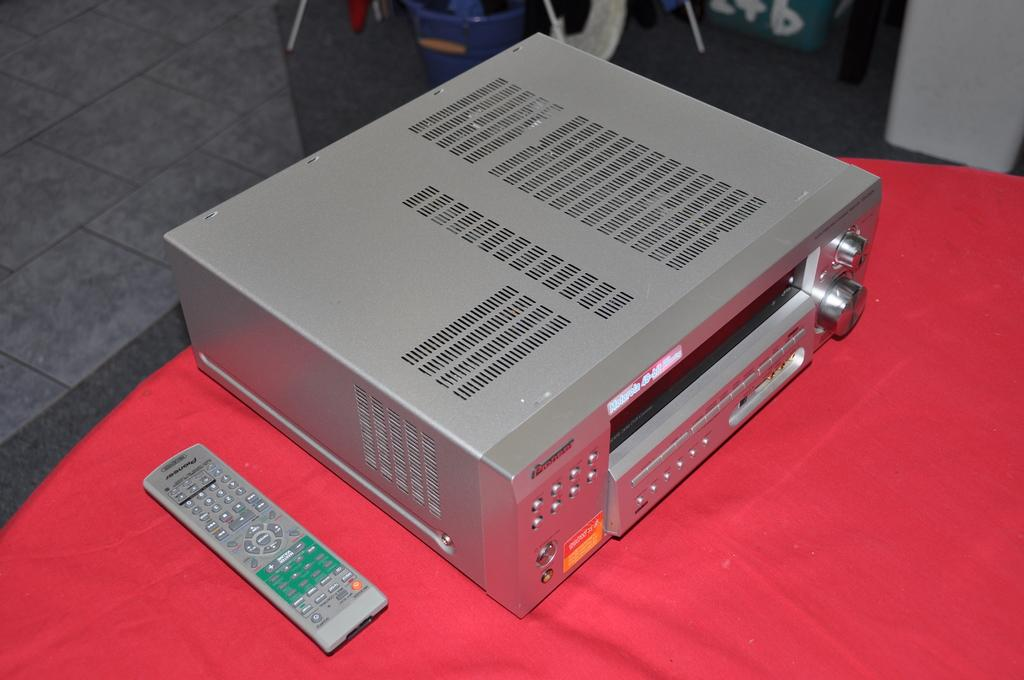Provide a one-sentence caption for the provided image. An old television device from Pioneer that plays 48-bit. 